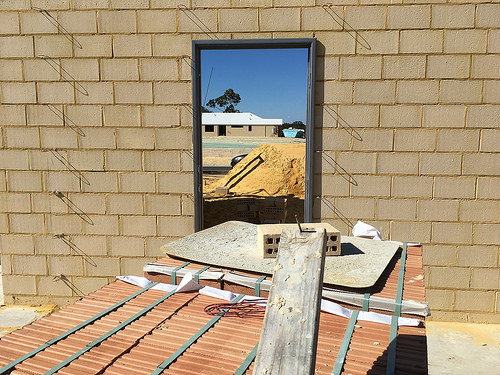<image>
Is there a sand in front of the mirror? Yes. The sand is positioned in front of the mirror, appearing closer to the camera viewpoint. 